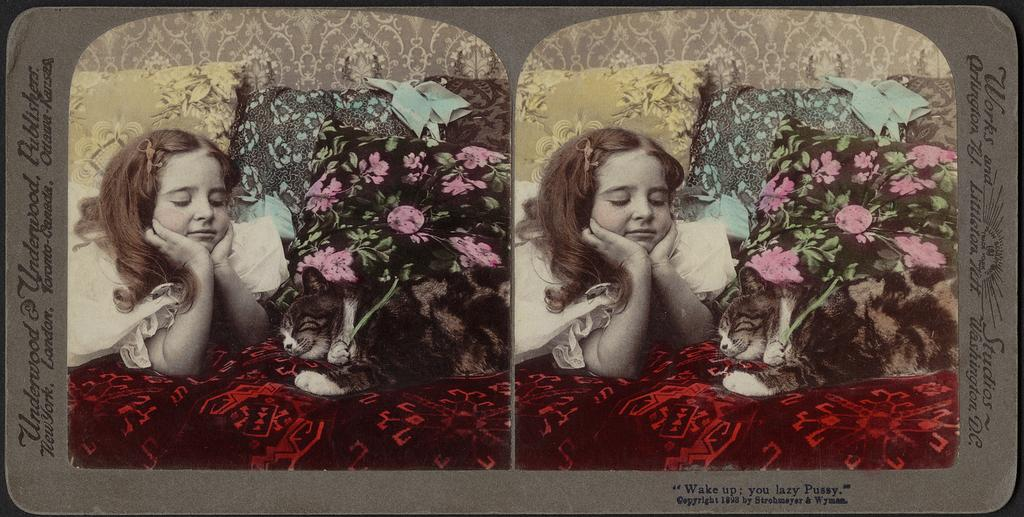What is the main subject of the card in the image? The card has a picture of a girl. Are there any other elements in the picture on the card? Yes, the picture on the card includes a cat and pillows. Reasoning: Let' Let's think step by step in order to produce the conversation. We start by identifying the main subject of the card, which is the girl. Then, we expand the conversation to include other elements in the picture on the card, such as the cat and pillows. Each question is designed to elicit a specific detail about the image that is known from the provided facts. Absurd Question/Answer: What time of day is depicted in the image? The provided facts do not mention the time of day, so it cannot be determined from the image. How many points does the cat have on its body in the image? There are no points mentioned or visible on the cat in the image. 